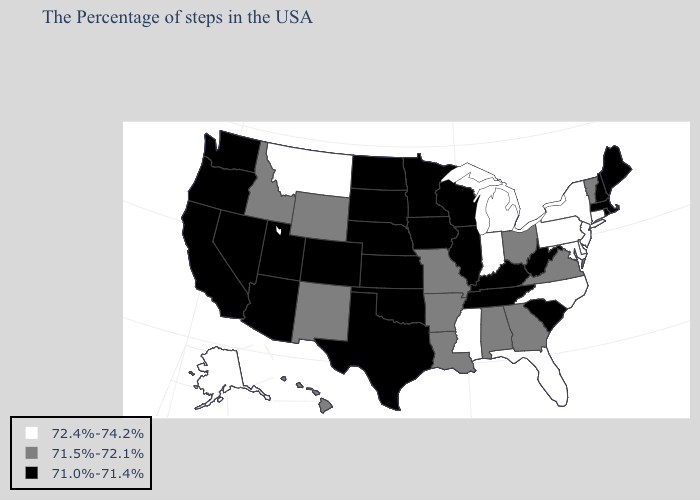What is the value of Arizona?
Concise answer only. 71.0%-71.4%. What is the value of Michigan?
Be succinct. 72.4%-74.2%. What is the highest value in states that border Montana?
Answer briefly. 71.5%-72.1%. Name the states that have a value in the range 71.0%-71.4%?
Quick response, please. Maine, Massachusetts, Rhode Island, New Hampshire, South Carolina, West Virginia, Kentucky, Tennessee, Wisconsin, Illinois, Minnesota, Iowa, Kansas, Nebraska, Oklahoma, Texas, South Dakota, North Dakota, Colorado, Utah, Arizona, Nevada, California, Washington, Oregon. Does Alaska have the lowest value in the West?
Give a very brief answer. No. Name the states that have a value in the range 72.4%-74.2%?
Give a very brief answer. Connecticut, New York, New Jersey, Delaware, Maryland, Pennsylvania, North Carolina, Florida, Michigan, Indiana, Mississippi, Montana, Alaska. What is the value of Florida?
Give a very brief answer. 72.4%-74.2%. What is the highest value in states that border West Virginia?
Short answer required. 72.4%-74.2%. How many symbols are there in the legend?
Concise answer only. 3. What is the lowest value in states that border Virginia?
Keep it brief. 71.0%-71.4%. What is the value of West Virginia?
Short answer required. 71.0%-71.4%. Name the states that have a value in the range 71.5%-72.1%?
Write a very short answer. Vermont, Virginia, Ohio, Georgia, Alabama, Louisiana, Missouri, Arkansas, Wyoming, New Mexico, Idaho, Hawaii. Does the map have missing data?
Short answer required. No. Does Tennessee have the highest value in the South?
Keep it brief. No. Does Massachusetts have the same value as Wyoming?
Answer briefly. No. 